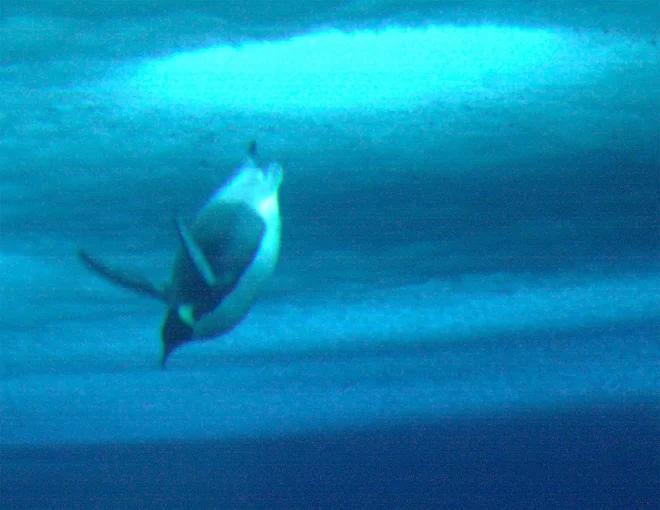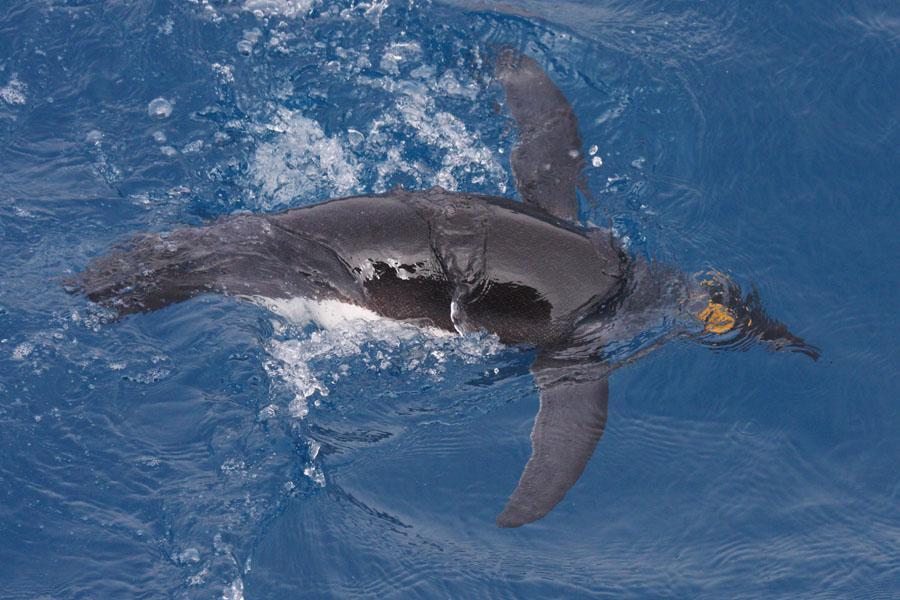The first image is the image on the left, the second image is the image on the right. Examine the images to the left and right. Is the description "There are more than 10 penguins swimming." accurate? Answer yes or no. No. 